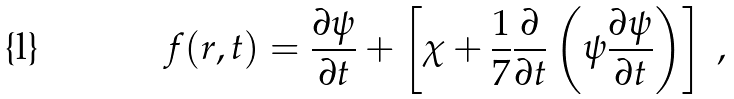<formula> <loc_0><loc_0><loc_500><loc_500>f ( r , t ) = \frac { \partial \psi } { \partial t } + \left [ \chi + \frac { 1 } { 7 } \frac { \partial } { \partial t } \left ( \psi \frac { \partial \psi } { \partial t } \right ) \right ] \ ,</formula> 